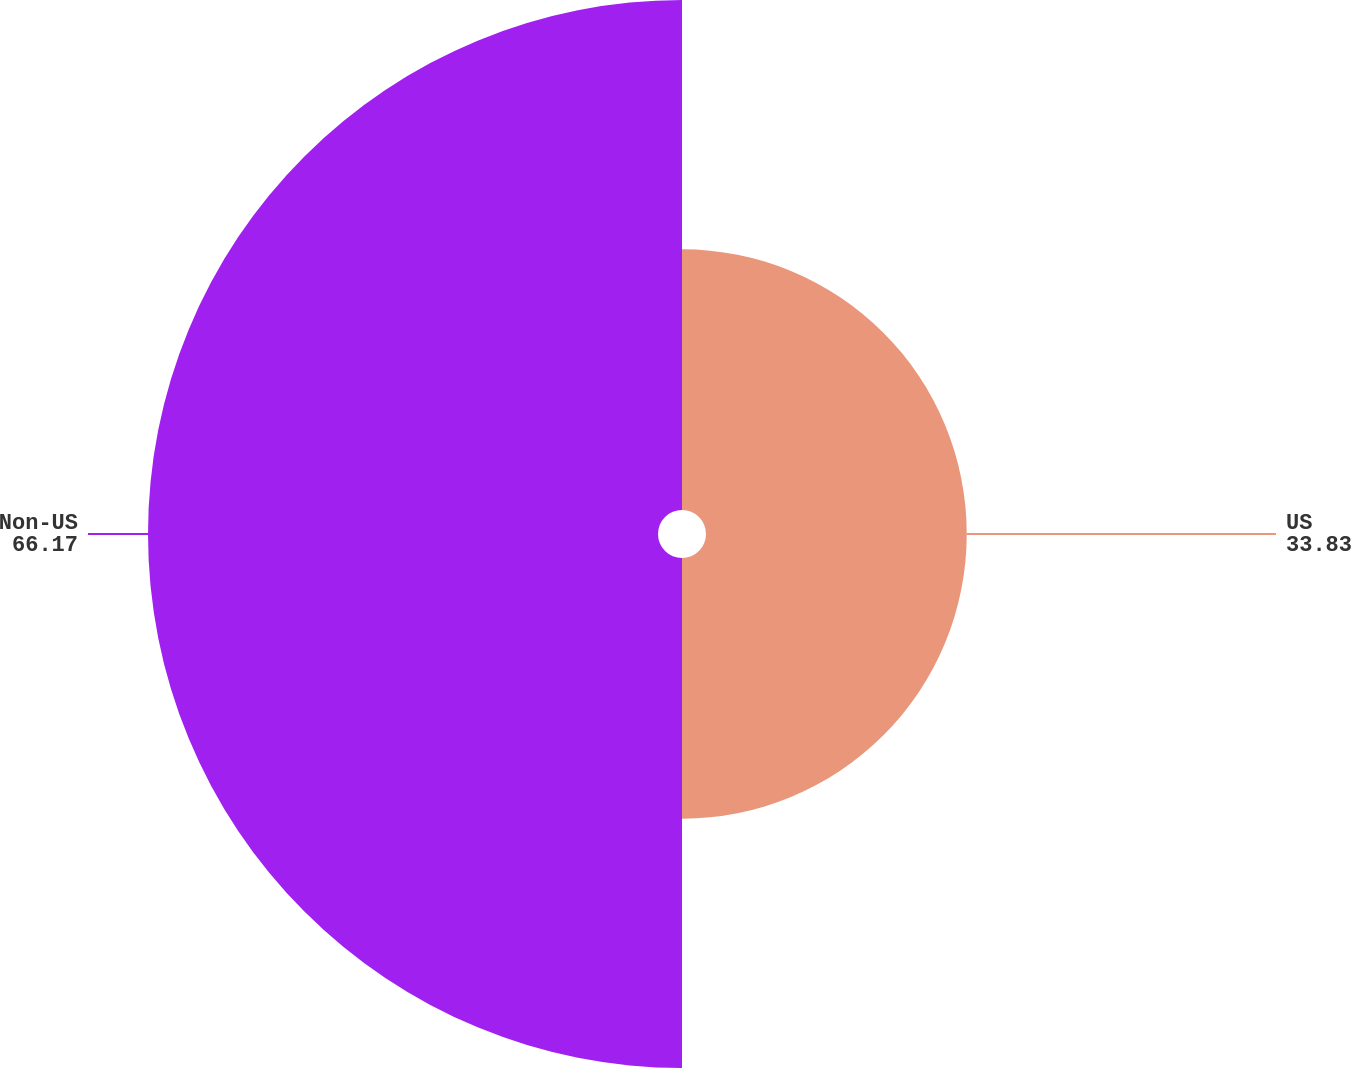<chart> <loc_0><loc_0><loc_500><loc_500><pie_chart><fcel>US<fcel>Non-US<nl><fcel>33.83%<fcel>66.17%<nl></chart> 